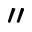Convert formula to latex. <formula><loc_0><loc_0><loc_500><loc_500>^ { \prime \prime }</formula> 